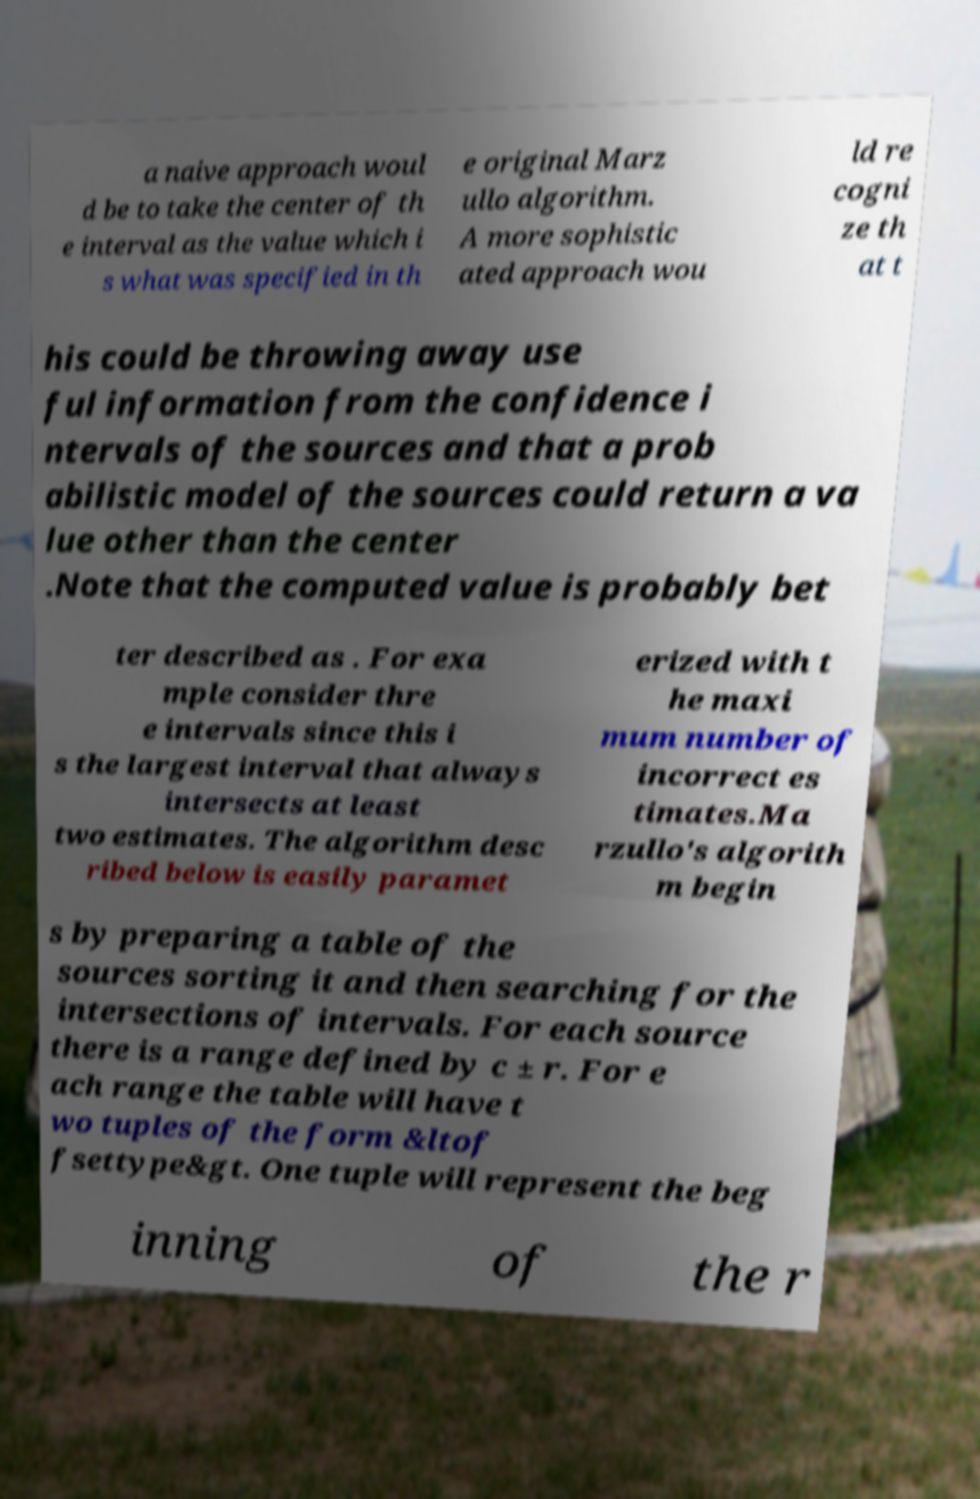Please identify and transcribe the text found in this image. a naive approach woul d be to take the center of th e interval as the value which i s what was specified in th e original Marz ullo algorithm. A more sophistic ated approach wou ld re cogni ze th at t his could be throwing away use ful information from the confidence i ntervals of the sources and that a prob abilistic model of the sources could return a va lue other than the center .Note that the computed value is probably bet ter described as . For exa mple consider thre e intervals since this i s the largest interval that always intersects at least two estimates. The algorithm desc ribed below is easily paramet erized with t he maxi mum number of incorrect es timates.Ma rzullo's algorith m begin s by preparing a table of the sources sorting it and then searching for the intersections of intervals. For each source there is a range defined by c ± r. For e ach range the table will have t wo tuples of the form &ltof fsettype&gt. One tuple will represent the beg inning of the r 